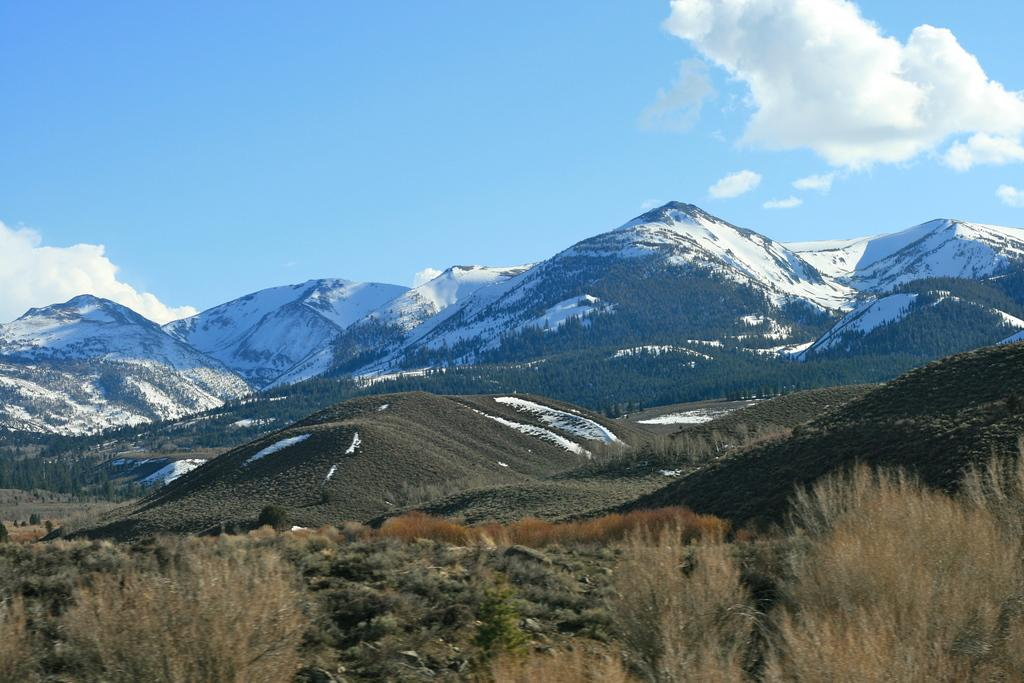What type of natural formation can be seen in the image? There are mountains in the image. What vegetation is present on the mountains? Plants and trees can be seen on the mountains. What is the condition of the mountains in the background? There is snow on the mountains in the background. What is visible at the top of the image? The sky is visible at the top of the image. Can you tell me how many representatives are present in the image? There are no representatives present in the image; it features mountains, plants, trees, snow, and the sky. Is there an airport visible in the image? There is no airport present in the image; it features mountains, plants, trees, snow, and the sky. 